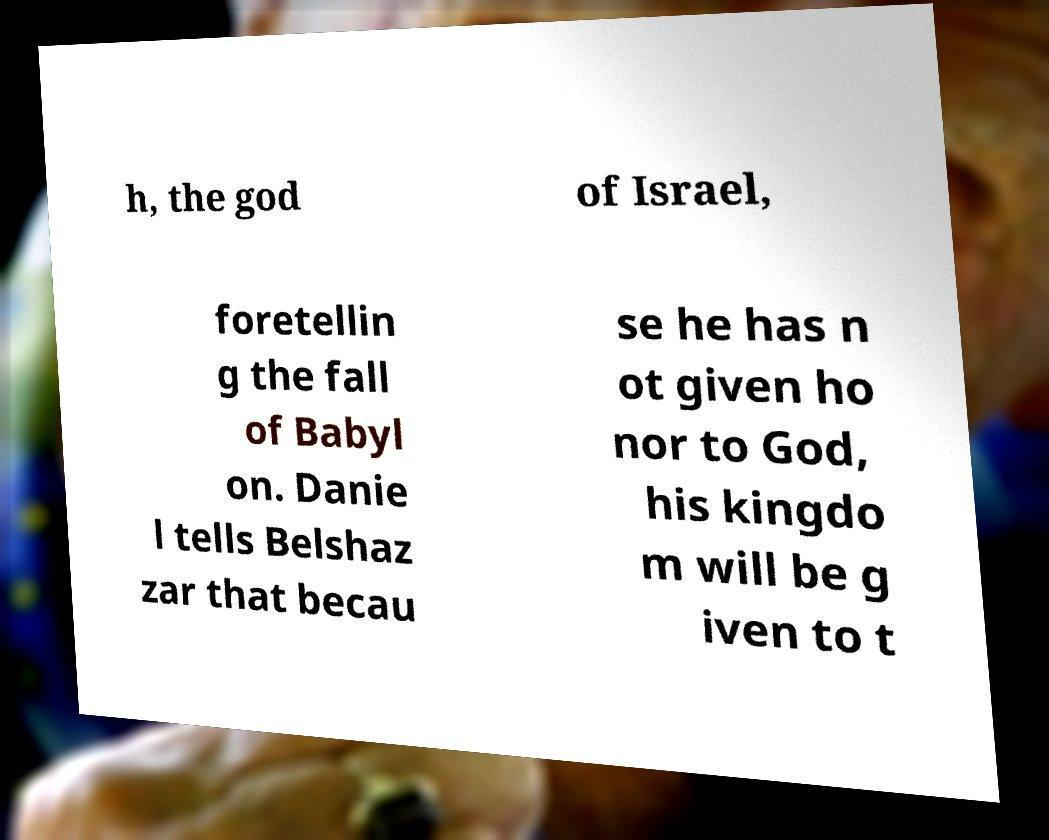Can you accurately transcribe the text from the provided image for me? h, the god of Israel, foretellin g the fall of Babyl on. Danie l tells Belshaz zar that becau se he has n ot given ho nor to God, his kingdo m will be g iven to t 